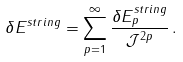<formula> <loc_0><loc_0><loc_500><loc_500>\delta E ^ { s t r i n g } = \sum _ { p = 1 } ^ { \infty } \frac { \delta E _ { p } ^ { s t r i n g } } { \mathcal { J } ^ { 2 p } } \, .</formula> 